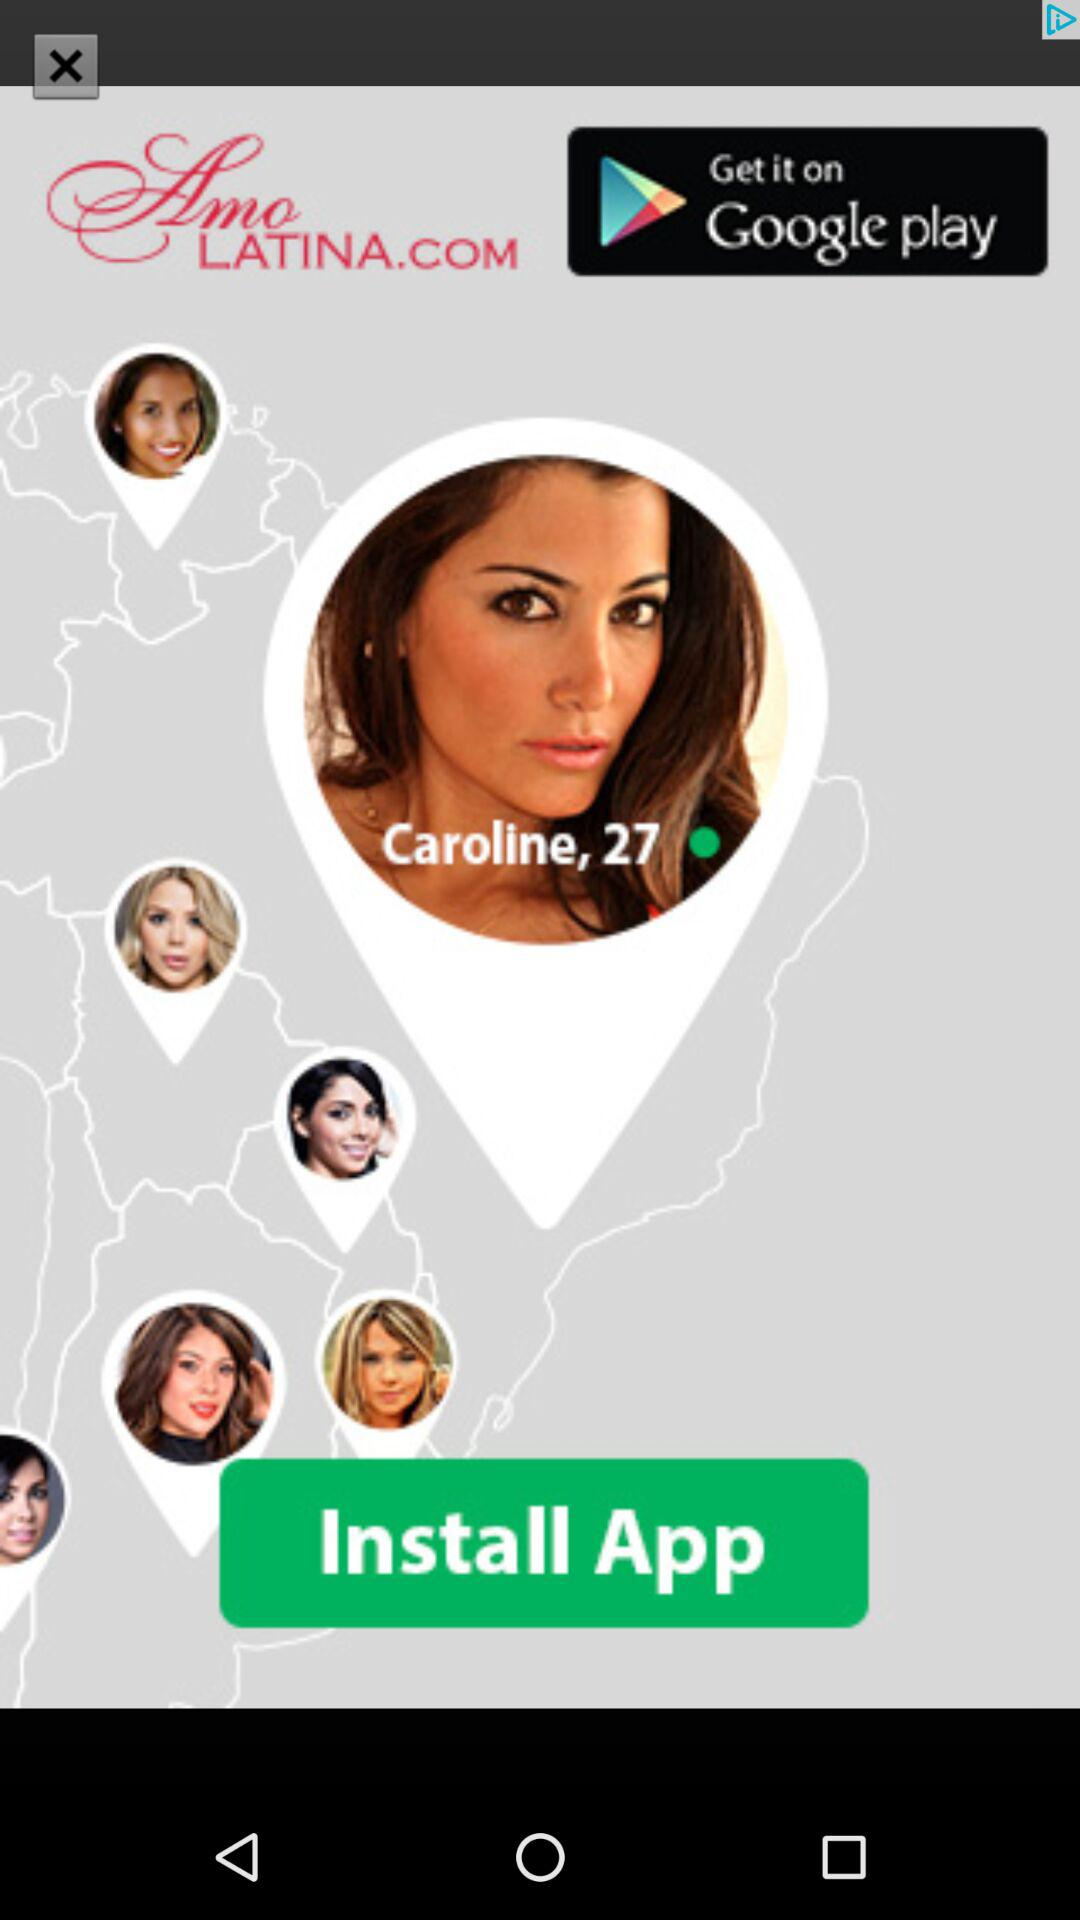From where can we download the app? You can download the application from "Google Play". 